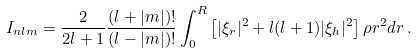Convert formula to latex. <formula><loc_0><loc_0><loc_500><loc_500>I _ { n l m } = \frac { 2 } { 2 l + 1 } \frac { ( l + | m | ) ! } { ( l - | m | ) ! } \int _ { 0 } ^ { R } \left [ | \xi _ { r } | ^ { 2 } + l ( l + 1 ) | \xi _ { h } | ^ { 2 } \right ] \rho r ^ { 2 } d r \, .</formula> 